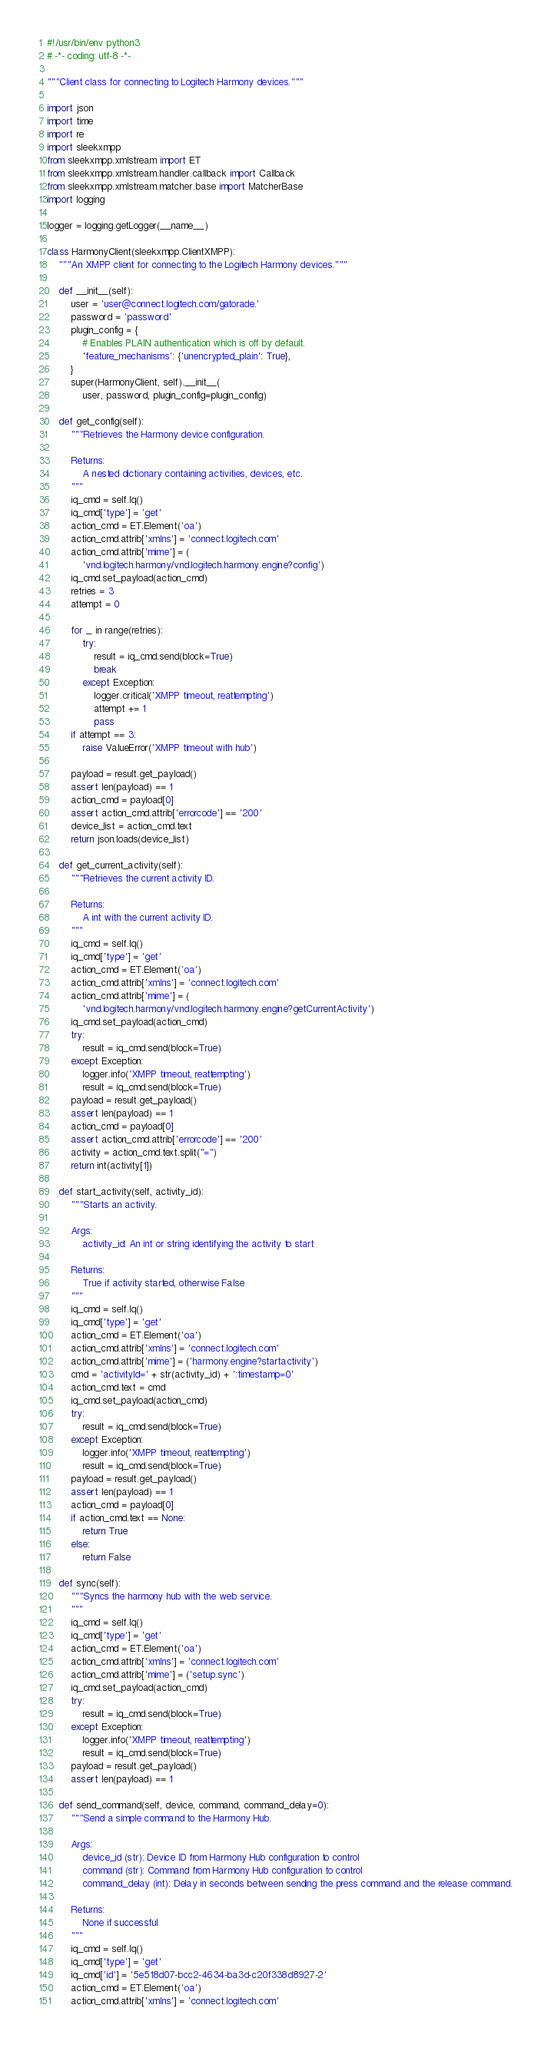<code> <loc_0><loc_0><loc_500><loc_500><_Python_>#!/usr/bin/env python3
# -*- coding: utf-8 -*-

"""Client class for connecting to Logitech Harmony devices."""

import json
import time
import re
import sleekxmpp
from sleekxmpp.xmlstream import ET
from sleekxmpp.xmlstream.handler.callback import Callback
from sleekxmpp.xmlstream.matcher.base import MatcherBase
import logging

logger = logging.getLogger(__name__)

class HarmonyClient(sleekxmpp.ClientXMPP):
    """An XMPP client for connecting to the Logitech Harmony devices."""

    def __init__(self):
        user = 'user@connect.logitech.com/gatorade.'
        password = 'password'
        plugin_config = {
            # Enables PLAIN authentication which is off by default.
            'feature_mechanisms': {'unencrypted_plain': True},
        }
        super(HarmonyClient, self).__init__(
            user, password, plugin_config=plugin_config)

    def get_config(self):
        """Retrieves the Harmony device configuration.

        Returns:
            A nested dictionary containing activities, devices, etc.
        """
        iq_cmd = self.Iq()
        iq_cmd['type'] = 'get'
        action_cmd = ET.Element('oa')
        action_cmd.attrib['xmlns'] = 'connect.logitech.com'
        action_cmd.attrib['mime'] = (
            'vnd.logitech.harmony/vnd.logitech.harmony.engine?config')
        iq_cmd.set_payload(action_cmd)
        retries = 3
        attempt = 0

        for _ in range(retries):
            try:
                result = iq_cmd.send(block=True)
                break
            except Exception:
                logger.critical('XMPP timeout, reattempting')
                attempt += 1
                pass
        if attempt == 3:
            raise ValueError('XMPP timeout with hub')

        payload = result.get_payload()
        assert len(payload) == 1
        action_cmd = payload[0]
        assert action_cmd.attrib['errorcode'] == '200'
        device_list = action_cmd.text
        return json.loads(device_list)

    def get_current_activity(self):
        """Retrieves the current activity ID.

        Returns:
            A int with the current activity ID.
        """
        iq_cmd = self.Iq()
        iq_cmd['type'] = 'get'
        action_cmd = ET.Element('oa')
        action_cmd.attrib['xmlns'] = 'connect.logitech.com'
        action_cmd.attrib['mime'] = (
            'vnd.logitech.harmony/vnd.logitech.harmony.engine?getCurrentActivity')
        iq_cmd.set_payload(action_cmd)
        try:
            result = iq_cmd.send(block=True)
        except Exception:
            logger.info('XMPP timeout, reattempting')
            result = iq_cmd.send(block=True)
        payload = result.get_payload()
        assert len(payload) == 1
        action_cmd = payload[0]
        assert action_cmd.attrib['errorcode'] == '200'
        activity = action_cmd.text.split("=")
        return int(activity[1])

    def start_activity(self, activity_id):
        """Starts an activity.

        Args:
            activity_id: An int or string identifying the activity to start

        Returns:
            True if activity started, otherwise False
        """
        iq_cmd = self.Iq()
        iq_cmd['type'] = 'get'
        action_cmd = ET.Element('oa')
        action_cmd.attrib['xmlns'] = 'connect.logitech.com'
        action_cmd.attrib['mime'] = ('harmony.engine?startactivity')
        cmd = 'activityId=' + str(activity_id) + ':timestamp=0'
        action_cmd.text = cmd
        iq_cmd.set_payload(action_cmd)
        try:
            result = iq_cmd.send(block=True)
        except Exception:
            logger.info('XMPP timeout, reattempting')
            result = iq_cmd.send(block=True)
        payload = result.get_payload()
        assert len(payload) == 1
        action_cmd = payload[0]
        if action_cmd.text == None:
            return True
        else:
            return False

    def sync(self):
        """Syncs the harmony hub with the web service.
        """
        iq_cmd = self.Iq()
        iq_cmd['type'] = 'get'
        action_cmd = ET.Element('oa')
        action_cmd.attrib['xmlns'] = 'connect.logitech.com'
        action_cmd.attrib['mime'] = ('setup.sync')
        iq_cmd.set_payload(action_cmd)
        try:
            result = iq_cmd.send(block=True)
        except Exception:
            logger.info('XMPP timeout, reattempting')
            result = iq_cmd.send(block=True)
        payload = result.get_payload()
        assert len(payload) == 1

    def send_command(self, device, command, command_delay=0):
        """Send a simple command to the Harmony Hub.

        Args:
            device_id (str): Device ID from Harmony Hub configuration to control
            command (str): Command from Harmony Hub configuration to control
            command_delay (int): Delay in seconds between sending the press command and the release command.

        Returns:
            None if successful
        """
        iq_cmd = self.Iq()
        iq_cmd['type'] = 'get'
        iq_cmd['id'] = '5e518d07-bcc2-4634-ba3d-c20f338d8927-2'
        action_cmd = ET.Element('oa')
        action_cmd.attrib['xmlns'] = 'connect.logitech.com'</code> 